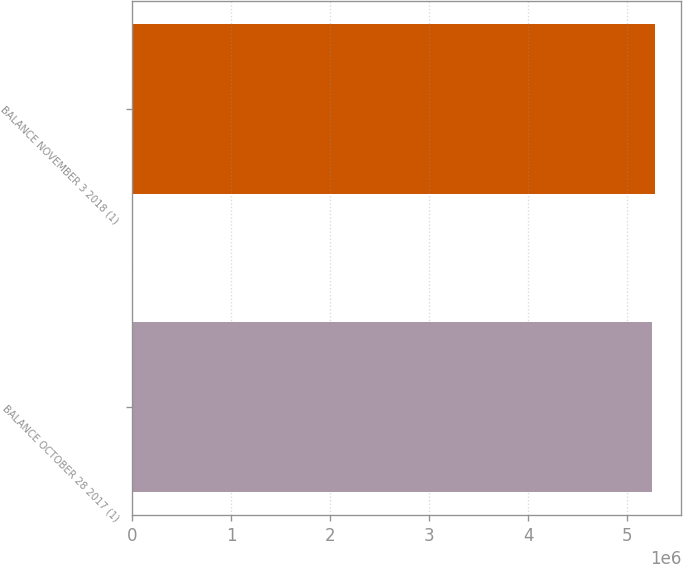<chart> <loc_0><loc_0><loc_500><loc_500><bar_chart><fcel>BALANCE OCTOBER 28 2017 (1)<fcel>BALANCE NOVEMBER 3 2018 (1)<nl><fcel>5.25052e+06<fcel>5.28222e+06<nl></chart> 